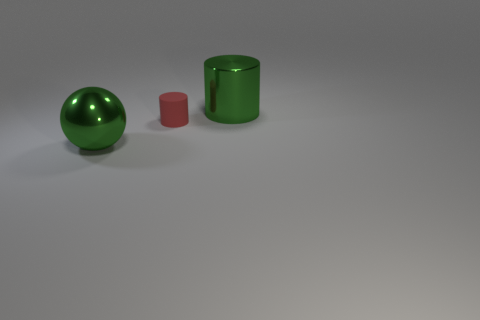Add 1 gray metallic blocks. How many objects exist? 4 Subtract all spheres. How many objects are left? 2 Add 3 large blue metallic objects. How many large blue metallic objects exist? 3 Subtract 0 green blocks. How many objects are left? 3 Subtract all green cylinders. Subtract all shiny cylinders. How many objects are left? 1 Add 3 tiny cylinders. How many tiny cylinders are left? 4 